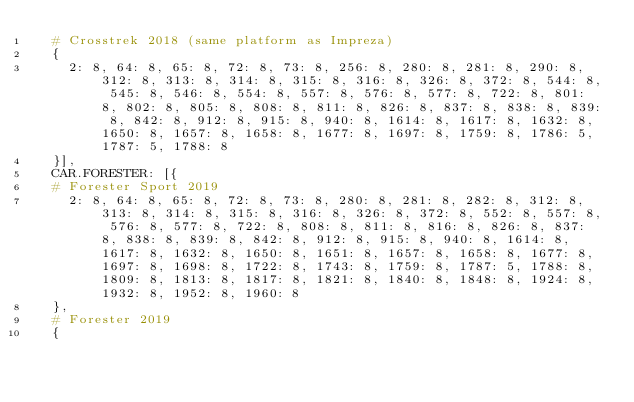<code> <loc_0><loc_0><loc_500><loc_500><_Python_>  # Crosstrek 2018 (same platform as Impreza)
  {
    2: 8, 64: 8, 65: 8, 72: 8, 73: 8, 256: 8, 280: 8, 281: 8, 290: 8, 312: 8, 313: 8, 314: 8, 315: 8, 316: 8, 326: 8, 372: 8, 544: 8, 545: 8, 546: 8, 554: 8, 557: 8, 576: 8, 577: 8, 722: 8, 801: 8, 802: 8, 805: 8, 808: 8, 811: 8, 826: 8, 837: 8, 838: 8, 839: 8, 842: 8, 912: 8, 915: 8, 940: 8, 1614: 8, 1617: 8, 1632: 8, 1650: 8, 1657: 8, 1658: 8, 1677: 8, 1697: 8, 1759: 8, 1786: 5, 1787: 5, 1788: 8
  }],
  CAR.FORESTER: [{
  # Forester Sport 2019
    2: 8, 64: 8, 65: 8, 72: 8, 73: 8, 280: 8, 281: 8, 282: 8, 312: 8, 313: 8, 314: 8, 315: 8, 316: 8, 326: 8, 372: 8, 552: 8, 557: 8, 576: 8, 577: 8, 722: 8, 808: 8, 811: 8, 816: 8, 826: 8, 837: 8, 838: 8, 839: 8, 842: 8, 912: 8, 915: 8, 940: 8, 1614: 8, 1617: 8, 1632: 8, 1650: 8, 1651: 8, 1657: 8, 1658: 8, 1677: 8, 1697: 8, 1698: 8, 1722: 8, 1743: 8, 1759: 8, 1787: 5, 1788: 8, 1809: 8, 1813: 8, 1817: 8, 1821: 8, 1840: 8, 1848: 8, 1924: 8, 1932: 8, 1952: 8, 1960: 8
  },
  # Forester 2019
  {</code> 